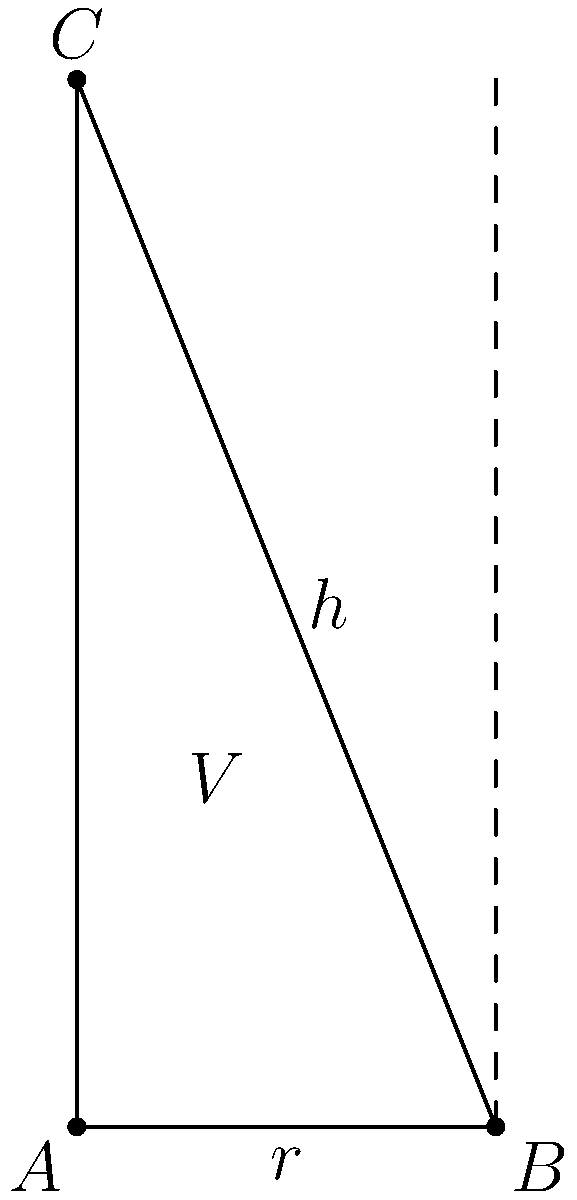A solid shampoo bar is designed in the shape of a cone to minimize packaging waste. The volume of the shampoo bar is fixed at $20\pi$ cubic centimeters. If the height of the cone is $h$ cm and the radius of the base is $r$ cm, what is the optimal ratio of $h$ to $r$ that minimizes the surface area of the cone, thereby reducing packaging material? To solve this problem, we'll follow these steps:

1) The volume of a cone is given by $V = \frac{1}{3}\pi r^2h$. We're told that $V = 20\pi$ cm³, so:

   $20\pi = \frac{1}{3}\pi r^2h$

2) Simplify this equation:

   $60 = r^2h$

3) The surface area of a cone (excluding the base) is given by $S = \pi r\sqrt{r^2 + h^2}$

4) We want to minimize $S$ with respect to $r$ and $h$, subject to the constraint $60 = r^2h$

5) We can express $h$ in terms of $r$ using the constraint:

   $h = \frac{60}{r^2}$

6) Substitute this into the surface area formula:

   $S = \pi r\sqrt{r^2 + (\frac{60}{r^2})^2}$

7) To minimize $S$, we differentiate with respect to $r$ and set it to zero:

   $\frac{dS}{dr} = \pi\sqrt{r^2 + (\frac{60}{r^2})^2} + \pi r\frac{r^2 - (\frac{60}{r^2})^2}{r\sqrt{r^2 + (\frac{60}{r^2})^2}} = 0$

8) This simplifies to:

   $r^4 = 3600$

9) Solving this:

   $r = \sqrt[4]{3600} = 6$

10) Now we can find $h$:

    $h = \frac{60}{r^2} = \frac{60}{36} = \frac{5}{3}$

11) The optimal ratio of $h$ to $r$ is therefore:

    $\frac{h}{r} = \frac{5/3}{6} = \frac{5}{18}$

This ratio minimizes the surface area of the cone, thus reducing packaging material.
Answer: $\frac{5}{18}$ 